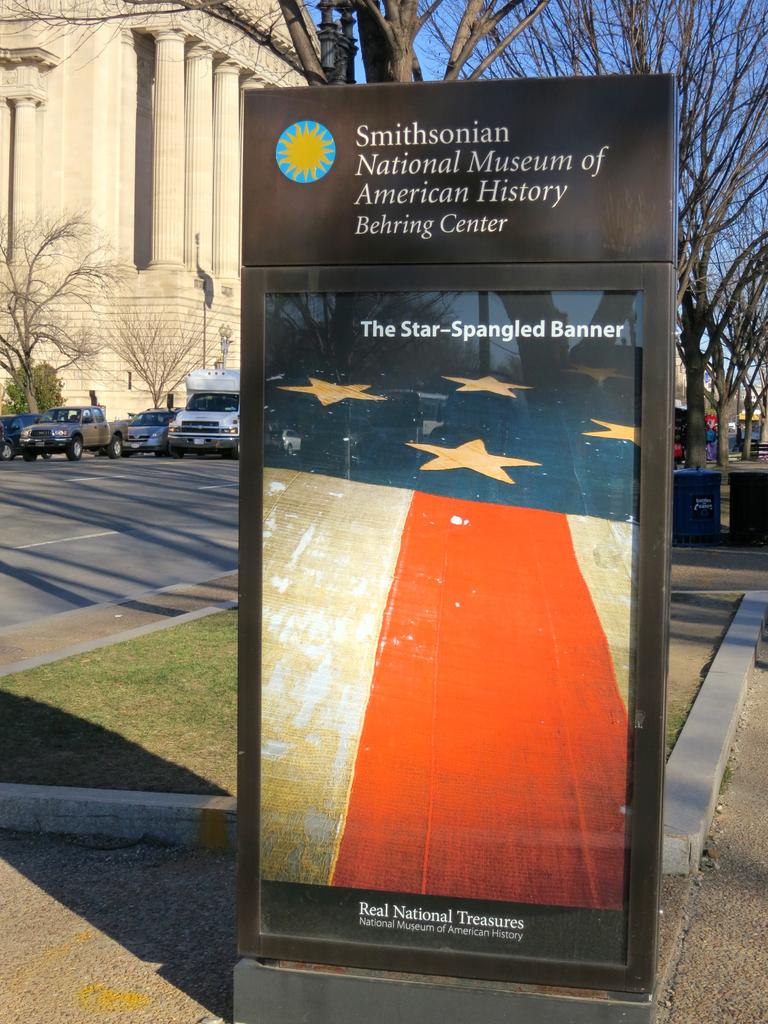What is the name of the center?
Your response must be concise. Smithsonian. What is the subject of this display by the smithsonian?
Give a very brief answer. The star-spangled banner. 